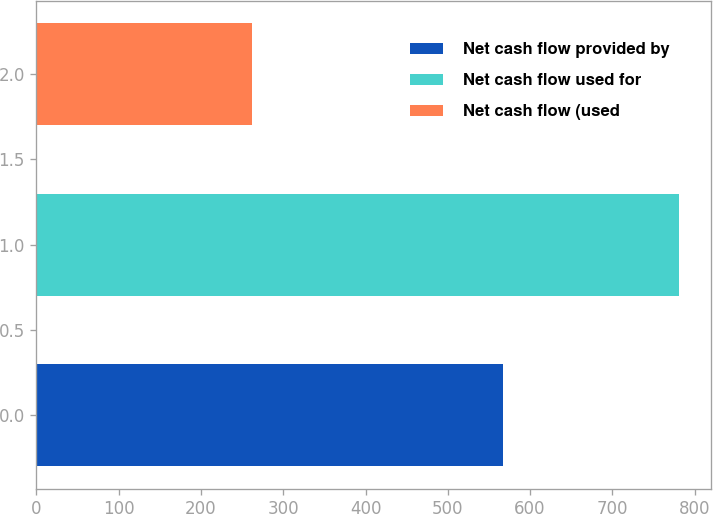<chart> <loc_0><loc_0><loc_500><loc_500><bar_chart><fcel>Net cash flow provided by<fcel>Net cash flow used for<fcel>Net cash flow (used<nl><fcel>567.6<fcel>781.4<fcel>262.4<nl></chart> 